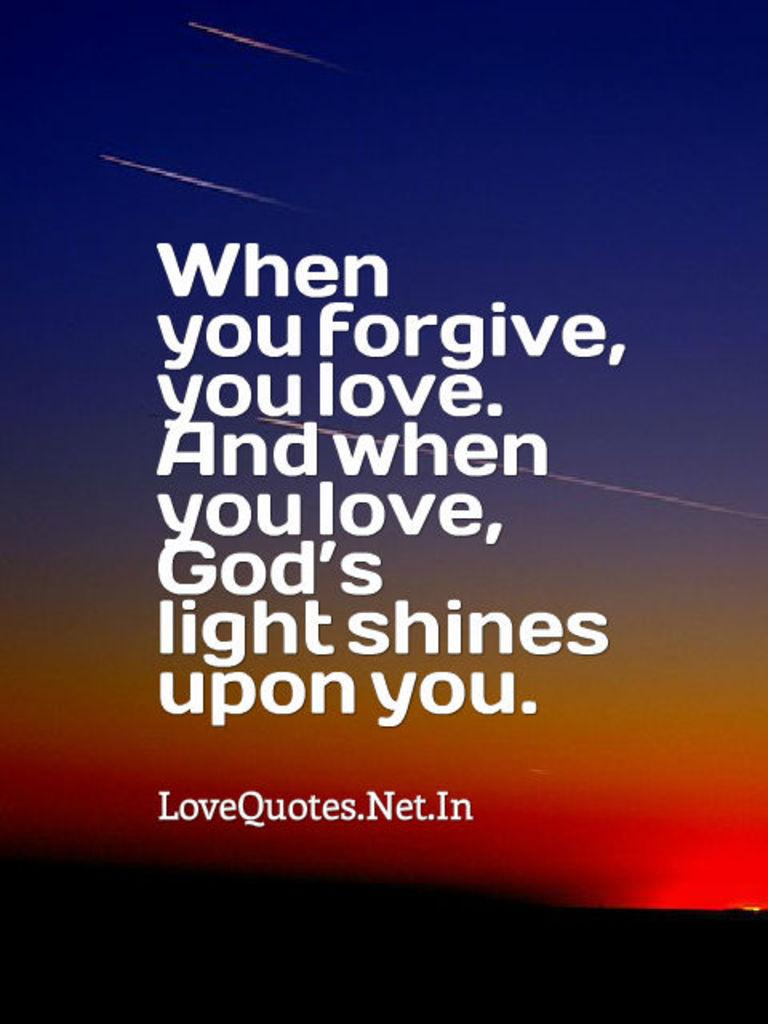Provide a one-sentence caption for the provided image. An inspirational poster has the phrase "When you forgive, you love. And when you love, God's light shines upon you" written on it. 